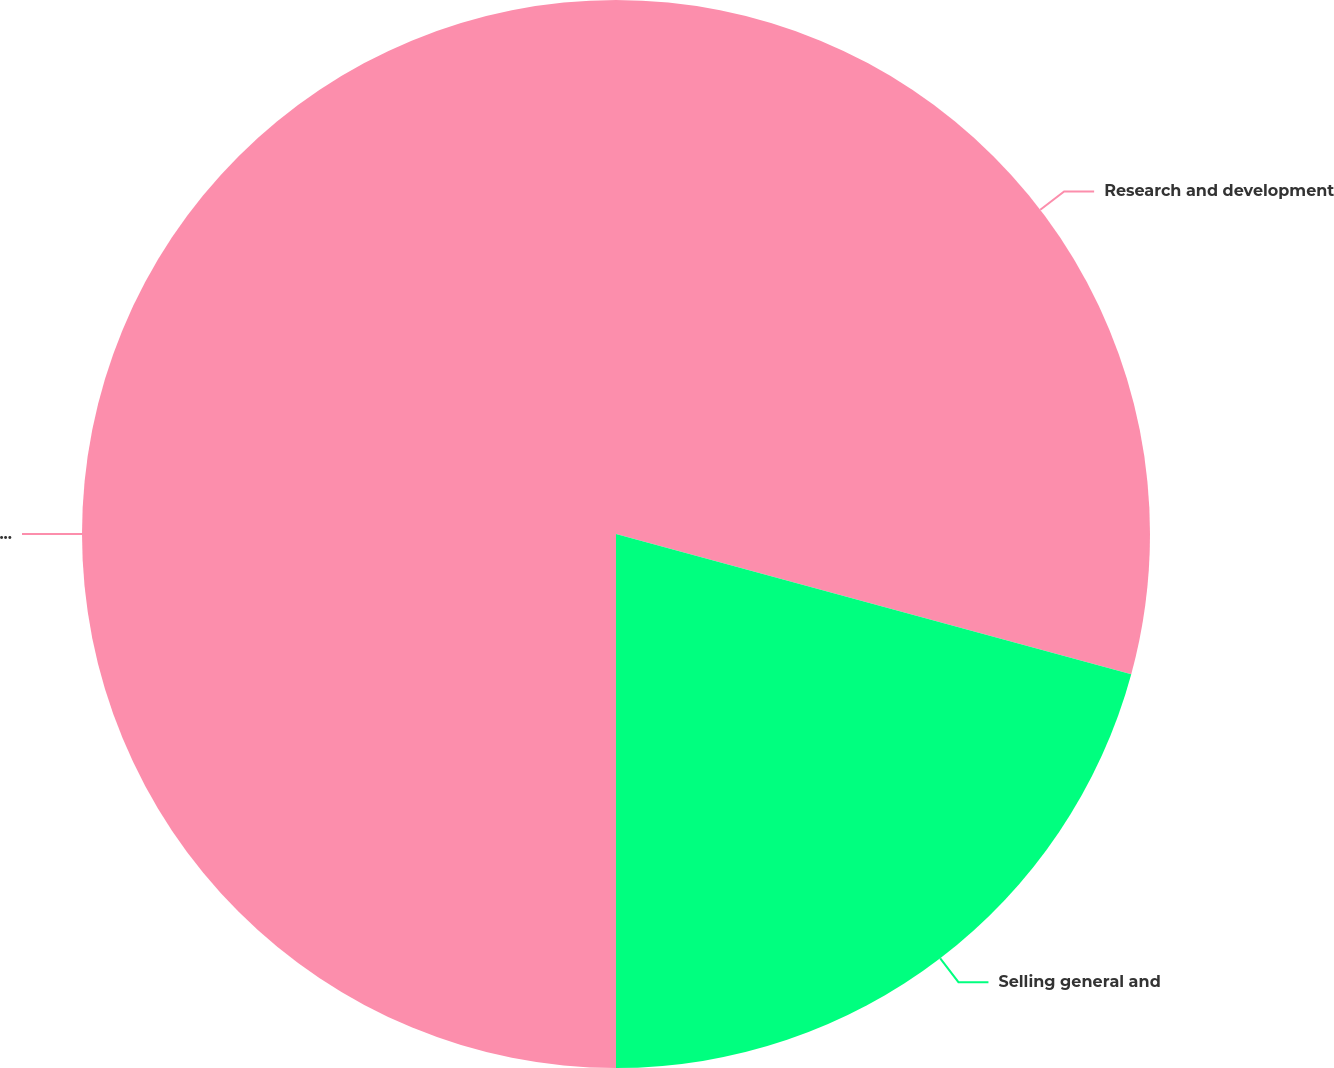<chart> <loc_0><loc_0><loc_500><loc_500><pie_chart><fcel>Research and development<fcel>Selling general and<fcel>Total operating expenses<nl><fcel>29.23%<fcel>20.77%<fcel>50.0%<nl></chart> 